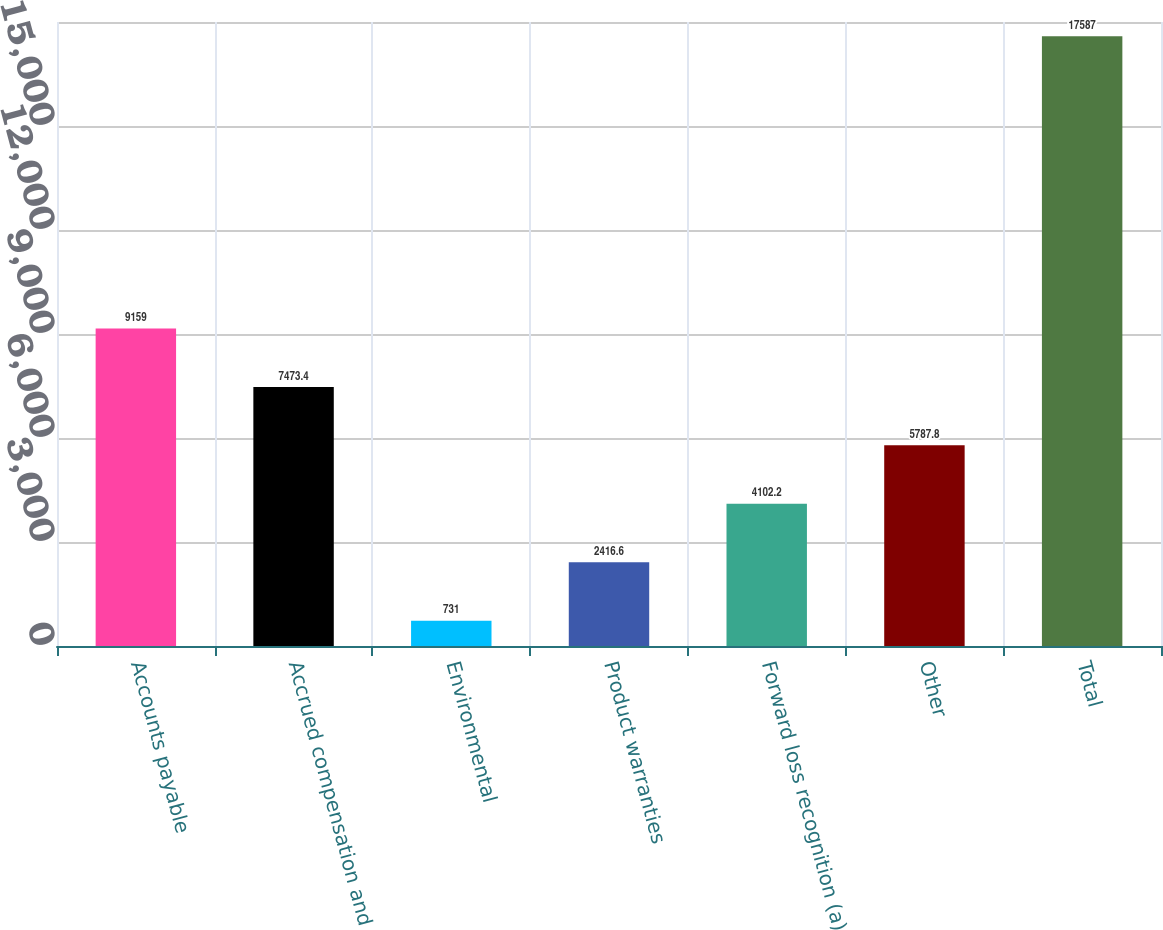<chart> <loc_0><loc_0><loc_500><loc_500><bar_chart><fcel>Accounts payable<fcel>Accrued compensation and<fcel>Environmental<fcel>Product warranties<fcel>Forward loss recognition (a)<fcel>Other<fcel>Total<nl><fcel>9159<fcel>7473.4<fcel>731<fcel>2416.6<fcel>4102.2<fcel>5787.8<fcel>17587<nl></chart> 